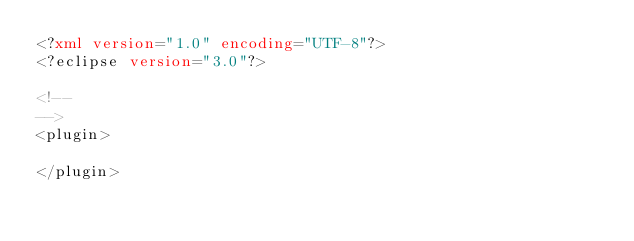Convert code to text. <code><loc_0><loc_0><loc_500><loc_500><_XML_><?xml version="1.0" encoding="UTF-8"?>
<?eclipse version="3.0"?>

<!--
-->
<plugin>

</plugin>
</code> 